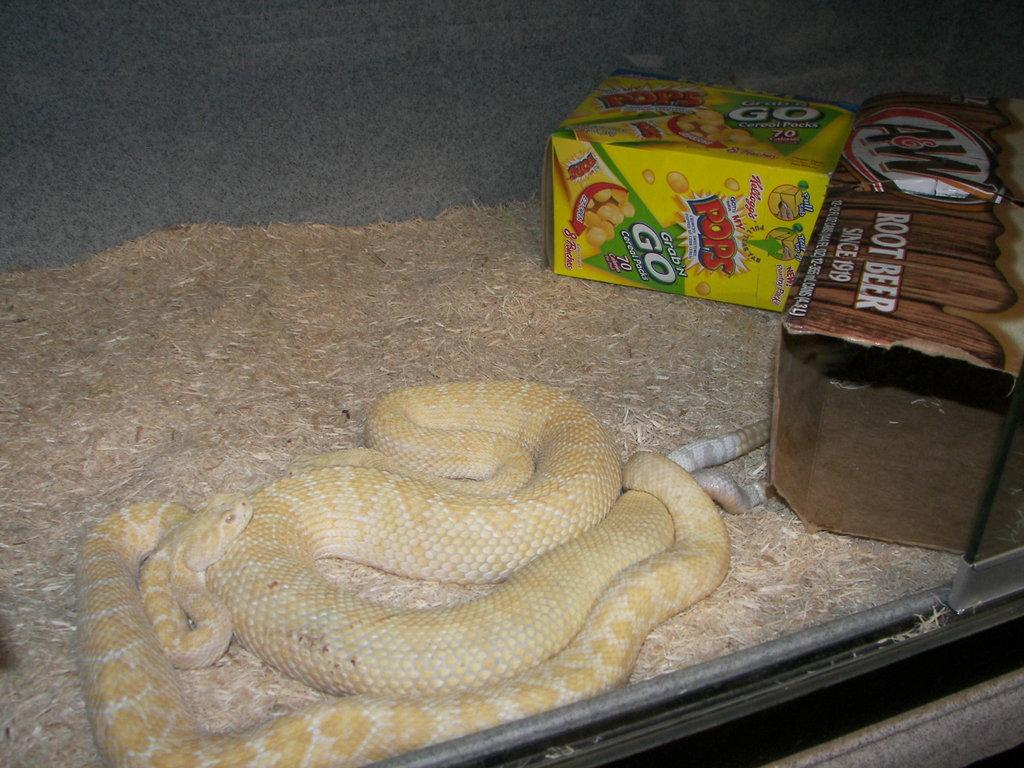What type of animal is present in the image? There is a snake in the image. What else can be seen in the image besides the snake? There are boxes with text and images in the image, as well as dry grass. What type of cabbage is being served for breakfast in the image? There is no cabbage or breakfast depicted in the image; it features a snake, boxes with text and images, and dry grass. 